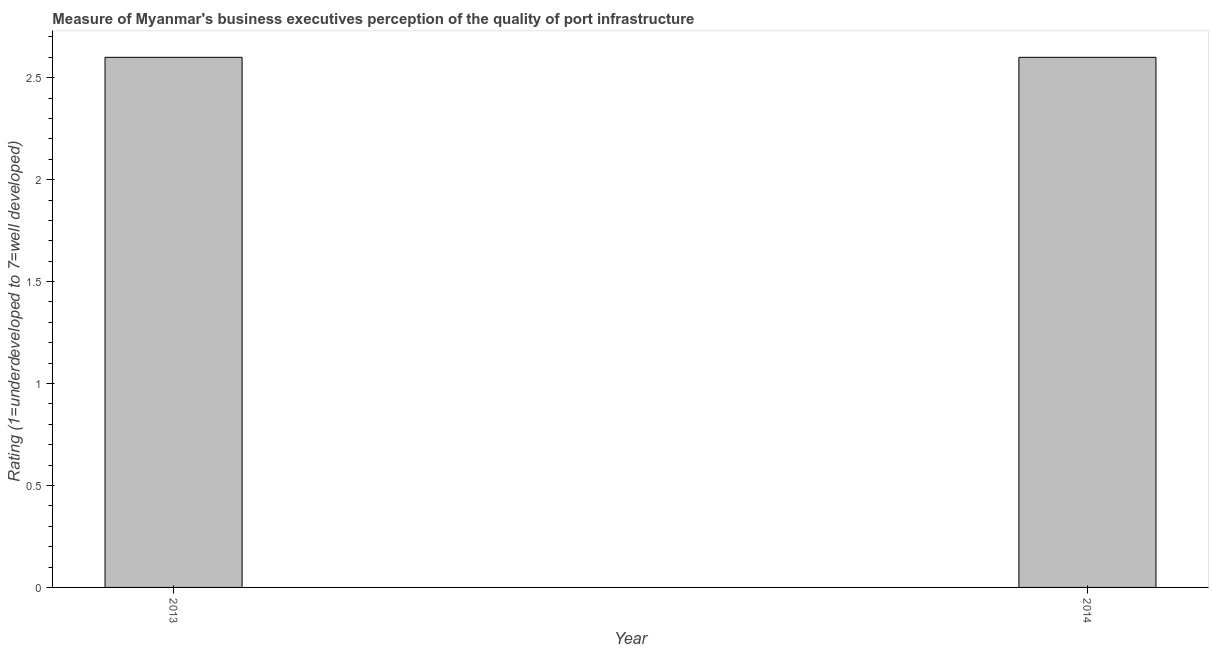Does the graph contain any zero values?
Make the answer very short. No. Does the graph contain grids?
Keep it short and to the point. No. What is the title of the graph?
Your answer should be very brief. Measure of Myanmar's business executives perception of the quality of port infrastructure. What is the label or title of the Y-axis?
Your response must be concise. Rating (1=underdeveloped to 7=well developed) . What is the rating measuring quality of port infrastructure in 2013?
Your answer should be compact. 2.6. Across all years, what is the maximum rating measuring quality of port infrastructure?
Your answer should be compact. 2.6. Across all years, what is the minimum rating measuring quality of port infrastructure?
Make the answer very short. 2.6. In which year was the rating measuring quality of port infrastructure maximum?
Ensure brevity in your answer.  2013. In which year was the rating measuring quality of port infrastructure minimum?
Ensure brevity in your answer.  2013. What is the difference between the rating measuring quality of port infrastructure in 2013 and 2014?
Ensure brevity in your answer.  0. In how many years, is the rating measuring quality of port infrastructure greater than 0.4 ?
Provide a short and direct response. 2. Do a majority of the years between 2014 and 2013 (inclusive) have rating measuring quality of port infrastructure greater than 0.8 ?
Your answer should be very brief. No. What is the ratio of the rating measuring quality of port infrastructure in 2013 to that in 2014?
Ensure brevity in your answer.  1. Is the rating measuring quality of port infrastructure in 2013 less than that in 2014?
Your answer should be compact. No. In how many years, is the rating measuring quality of port infrastructure greater than the average rating measuring quality of port infrastructure taken over all years?
Give a very brief answer. 0. Are all the bars in the graph horizontal?
Ensure brevity in your answer.  No. How many years are there in the graph?
Offer a terse response. 2. Are the values on the major ticks of Y-axis written in scientific E-notation?
Make the answer very short. No. What is the Rating (1=underdeveloped to 7=well developed)  in 2013?
Make the answer very short. 2.6. What is the Rating (1=underdeveloped to 7=well developed)  of 2014?
Provide a succinct answer. 2.6. What is the difference between the Rating (1=underdeveloped to 7=well developed)  in 2013 and 2014?
Offer a very short reply. 0. What is the ratio of the Rating (1=underdeveloped to 7=well developed)  in 2013 to that in 2014?
Keep it short and to the point. 1. 